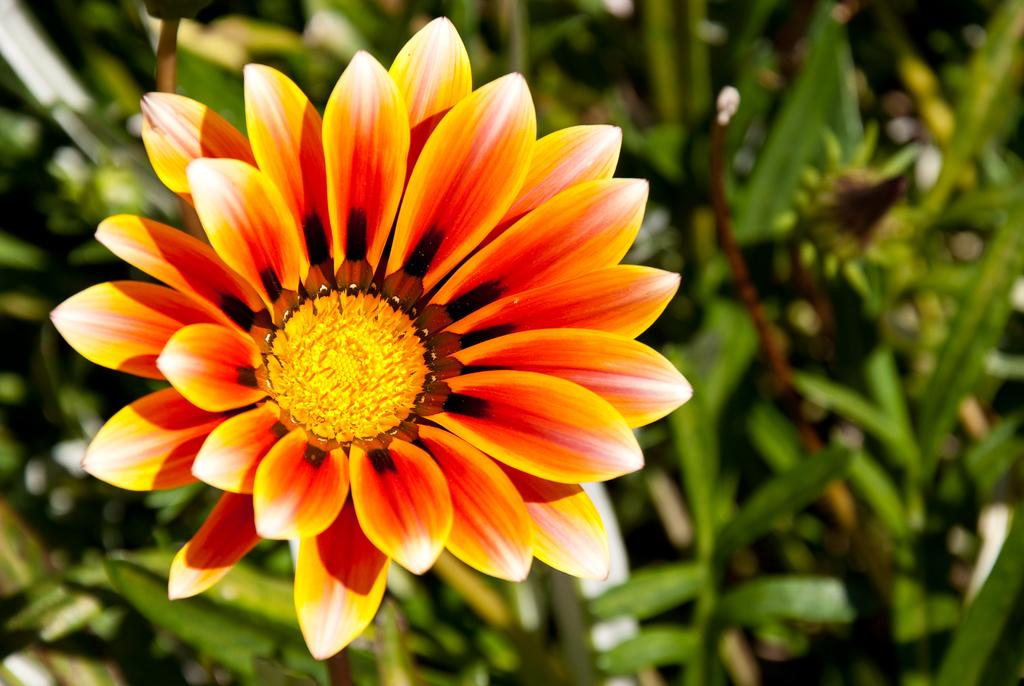What is the main subject in the foreground of the image? There is a flower in the foreground of the image. What can be seen in the background of the image? There are green leaves in the background of the image. Are there any other elements related to plants visible in the background? Yes, there are objects of the plants visible in the background of the image. What type of toothbrush can be seen in the image? There is no toothbrush present in the image. What kind of shoe is visible in the image? There is no shoe present in the image. 